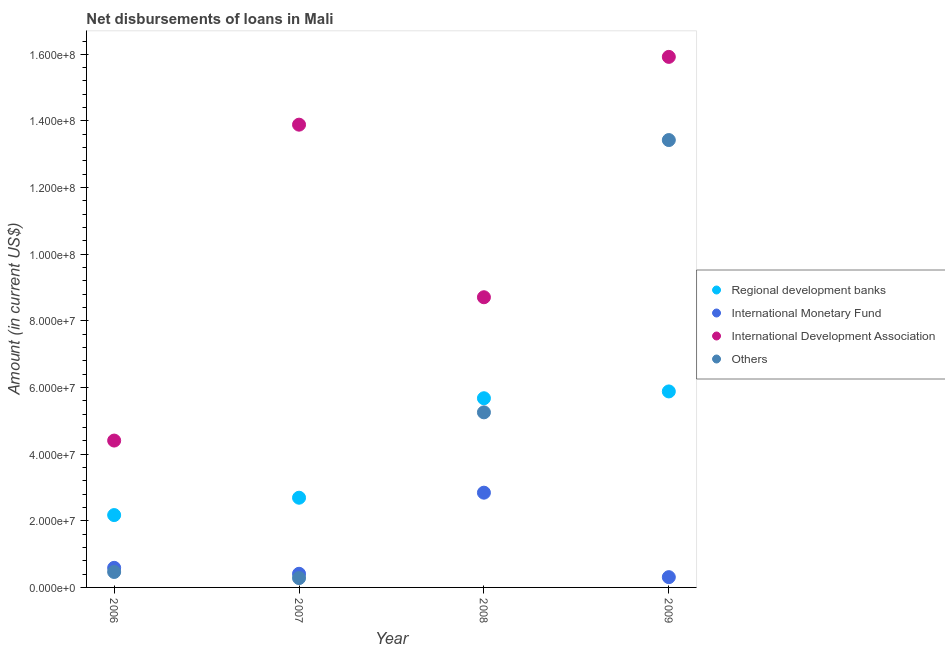How many different coloured dotlines are there?
Provide a succinct answer. 4. Is the number of dotlines equal to the number of legend labels?
Provide a succinct answer. Yes. What is the amount of loan disimbursed by international development association in 2006?
Provide a short and direct response. 4.41e+07. Across all years, what is the maximum amount of loan disimbursed by international monetary fund?
Your answer should be compact. 2.84e+07. Across all years, what is the minimum amount of loan disimbursed by international monetary fund?
Your answer should be compact. 3.08e+06. What is the total amount of loan disimbursed by international development association in the graph?
Your answer should be very brief. 4.29e+08. What is the difference between the amount of loan disimbursed by other organisations in 2007 and that in 2008?
Your answer should be compact. -4.97e+07. What is the difference between the amount of loan disimbursed by international development association in 2007 and the amount of loan disimbursed by other organisations in 2006?
Keep it short and to the point. 1.34e+08. What is the average amount of loan disimbursed by international monetary fund per year?
Keep it short and to the point. 1.04e+07. In the year 2007, what is the difference between the amount of loan disimbursed by international development association and amount of loan disimbursed by international monetary fund?
Give a very brief answer. 1.35e+08. What is the ratio of the amount of loan disimbursed by other organisations in 2007 to that in 2008?
Provide a short and direct response. 0.05. Is the amount of loan disimbursed by international monetary fund in 2007 less than that in 2008?
Offer a very short reply. Yes. Is the difference between the amount of loan disimbursed by regional development banks in 2007 and 2009 greater than the difference between the amount of loan disimbursed by international monetary fund in 2007 and 2009?
Offer a terse response. No. What is the difference between the highest and the second highest amount of loan disimbursed by international monetary fund?
Provide a short and direct response. 2.26e+07. What is the difference between the highest and the lowest amount of loan disimbursed by international development association?
Offer a terse response. 1.15e+08. Is it the case that in every year, the sum of the amount of loan disimbursed by regional development banks and amount of loan disimbursed by international monetary fund is greater than the amount of loan disimbursed by international development association?
Offer a terse response. No. Is the amount of loan disimbursed by international development association strictly greater than the amount of loan disimbursed by other organisations over the years?
Ensure brevity in your answer.  Yes. How many dotlines are there?
Keep it short and to the point. 4. Does the graph contain any zero values?
Give a very brief answer. No. Where does the legend appear in the graph?
Your response must be concise. Center right. How are the legend labels stacked?
Your response must be concise. Vertical. What is the title of the graph?
Give a very brief answer. Net disbursements of loans in Mali. Does "Insurance services" appear as one of the legend labels in the graph?
Make the answer very short. No. What is the Amount (in current US$) of Regional development banks in 2006?
Your response must be concise. 2.17e+07. What is the Amount (in current US$) in International Monetary Fund in 2006?
Offer a terse response. 5.88e+06. What is the Amount (in current US$) in International Development Association in 2006?
Make the answer very short. 4.41e+07. What is the Amount (in current US$) in Others in 2006?
Provide a short and direct response. 4.64e+06. What is the Amount (in current US$) in Regional development banks in 2007?
Your answer should be compact. 2.69e+07. What is the Amount (in current US$) of International Monetary Fund in 2007?
Your answer should be very brief. 4.09e+06. What is the Amount (in current US$) of International Development Association in 2007?
Make the answer very short. 1.39e+08. What is the Amount (in current US$) in Others in 2007?
Your response must be concise. 2.80e+06. What is the Amount (in current US$) in Regional development banks in 2008?
Your answer should be very brief. 5.68e+07. What is the Amount (in current US$) in International Monetary Fund in 2008?
Your answer should be very brief. 2.84e+07. What is the Amount (in current US$) of International Development Association in 2008?
Provide a succinct answer. 8.71e+07. What is the Amount (in current US$) in Others in 2008?
Keep it short and to the point. 5.25e+07. What is the Amount (in current US$) in Regional development banks in 2009?
Give a very brief answer. 5.88e+07. What is the Amount (in current US$) in International Monetary Fund in 2009?
Your answer should be compact. 3.08e+06. What is the Amount (in current US$) in International Development Association in 2009?
Ensure brevity in your answer.  1.59e+08. What is the Amount (in current US$) in Others in 2009?
Your response must be concise. 1.34e+08. Across all years, what is the maximum Amount (in current US$) of Regional development banks?
Provide a succinct answer. 5.88e+07. Across all years, what is the maximum Amount (in current US$) in International Monetary Fund?
Offer a very short reply. 2.84e+07. Across all years, what is the maximum Amount (in current US$) in International Development Association?
Provide a succinct answer. 1.59e+08. Across all years, what is the maximum Amount (in current US$) in Others?
Provide a succinct answer. 1.34e+08. Across all years, what is the minimum Amount (in current US$) in Regional development banks?
Your answer should be very brief. 2.17e+07. Across all years, what is the minimum Amount (in current US$) of International Monetary Fund?
Provide a short and direct response. 3.08e+06. Across all years, what is the minimum Amount (in current US$) of International Development Association?
Your response must be concise. 4.41e+07. Across all years, what is the minimum Amount (in current US$) in Others?
Offer a terse response. 2.80e+06. What is the total Amount (in current US$) in Regional development banks in the graph?
Offer a very short reply. 1.64e+08. What is the total Amount (in current US$) of International Monetary Fund in the graph?
Offer a terse response. 4.15e+07. What is the total Amount (in current US$) in International Development Association in the graph?
Offer a very short reply. 4.29e+08. What is the total Amount (in current US$) in Others in the graph?
Your response must be concise. 1.94e+08. What is the difference between the Amount (in current US$) of Regional development banks in 2006 and that in 2007?
Your response must be concise. -5.21e+06. What is the difference between the Amount (in current US$) of International Monetary Fund in 2006 and that in 2007?
Give a very brief answer. 1.79e+06. What is the difference between the Amount (in current US$) of International Development Association in 2006 and that in 2007?
Provide a short and direct response. -9.48e+07. What is the difference between the Amount (in current US$) in Others in 2006 and that in 2007?
Offer a very short reply. 1.83e+06. What is the difference between the Amount (in current US$) in Regional development banks in 2006 and that in 2008?
Make the answer very short. -3.51e+07. What is the difference between the Amount (in current US$) of International Monetary Fund in 2006 and that in 2008?
Offer a very short reply. -2.26e+07. What is the difference between the Amount (in current US$) in International Development Association in 2006 and that in 2008?
Give a very brief answer. -4.30e+07. What is the difference between the Amount (in current US$) of Others in 2006 and that in 2008?
Provide a succinct answer. -4.79e+07. What is the difference between the Amount (in current US$) in Regional development banks in 2006 and that in 2009?
Your answer should be compact. -3.71e+07. What is the difference between the Amount (in current US$) of International Monetary Fund in 2006 and that in 2009?
Keep it short and to the point. 2.80e+06. What is the difference between the Amount (in current US$) in International Development Association in 2006 and that in 2009?
Ensure brevity in your answer.  -1.15e+08. What is the difference between the Amount (in current US$) of Others in 2006 and that in 2009?
Keep it short and to the point. -1.30e+08. What is the difference between the Amount (in current US$) in Regional development banks in 2007 and that in 2008?
Your answer should be compact. -2.99e+07. What is the difference between the Amount (in current US$) in International Monetary Fund in 2007 and that in 2008?
Offer a terse response. -2.43e+07. What is the difference between the Amount (in current US$) in International Development Association in 2007 and that in 2008?
Your answer should be very brief. 5.18e+07. What is the difference between the Amount (in current US$) of Others in 2007 and that in 2008?
Provide a short and direct response. -4.97e+07. What is the difference between the Amount (in current US$) in Regional development banks in 2007 and that in 2009?
Offer a very short reply. -3.19e+07. What is the difference between the Amount (in current US$) in International Monetary Fund in 2007 and that in 2009?
Offer a terse response. 1.01e+06. What is the difference between the Amount (in current US$) of International Development Association in 2007 and that in 2009?
Give a very brief answer. -2.03e+07. What is the difference between the Amount (in current US$) of Others in 2007 and that in 2009?
Make the answer very short. -1.31e+08. What is the difference between the Amount (in current US$) in Regional development banks in 2008 and that in 2009?
Your response must be concise. -2.04e+06. What is the difference between the Amount (in current US$) in International Monetary Fund in 2008 and that in 2009?
Give a very brief answer. 2.54e+07. What is the difference between the Amount (in current US$) of International Development Association in 2008 and that in 2009?
Give a very brief answer. -7.21e+07. What is the difference between the Amount (in current US$) in Others in 2008 and that in 2009?
Make the answer very short. -8.17e+07. What is the difference between the Amount (in current US$) in Regional development banks in 2006 and the Amount (in current US$) in International Monetary Fund in 2007?
Your response must be concise. 1.76e+07. What is the difference between the Amount (in current US$) of Regional development banks in 2006 and the Amount (in current US$) of International Development Association in 2007?
Give a very brief answer. -1.17e+08. What is the difference between the Amount (in current US$) of Regional development banks in 2006 and the Amount (in current US$) of Others in 2007?
Your response must be concise. 1.89e+07. What is the difference between the Amount (in current US$) in International Monetary Fund in 2006 and the Amount (in current US$) in International Development Association in 2007?
Keep it short and to the point. -1.33e+08. What is the difference between the Amount (in current US$) of International Monetary Fund in 2006 and the Amount (in current US$) of Others in 2007?
Your answer should be compact. 3.08e+06. What is the difference between the Amount (in current US$) of International Development Association in 2006 and the Amount (in current US$) of Others in 2007?
Your answer should be compact. 4.13e+07. What is the difference between the Amount (in current US$) in Regional development banks in 2006 and the Amount (in current US$) in International Monetary Fund in 2008?
Make the answer very short. -6.72e+06. What is the difference between the Amount (in current US$) of Regional development banks in 2006 and the Amount (in current US$) of International Development Association in 2008?
Provide a succinct answer. -6.54e+07. What is the difference between the Amount (in current US$) in Regional development banks in 2006 and the Amount (in current US$) in Others in 2008?
Make the answer very short. -3.08e+07. What is the difference between the Amount (in current US$) in International Monetary Fund in 2006 and the Amount (in current US$) in International Development Association in 2008?
Offer a very short reply. -8.12e+07. What is the difference between the Amount (in current US$) in International Monetary Fund in 2006 and the Amount (in current US$) in Others in 2008?
Your response must be concise. -4.67e+07. What is the difference between the Amount (in current US$) of International Development Association in 2006 and the Amount (in current US$) of Others in 2008?
Your answer should be compact. -8.47e+06. What is the difference between the Amount (in current US$) of Regional development banks in 2006 and the Amount (in current US$) of International Monetary Fund in 2009?
Keep it short and to the point. 1.86e+07. What is the difference between the Amount (in current US$) of Regional development banks in 2006 and the Amount (in current US$) of International Development Association in 2009?
Provide a short and direct response. -1.38e+08. What is the difference between the Amount (in current US$) of Regional development banks in 2006 and the Amount (in current US$) of Others in 2009?
Offer a terse response. -1.13e+08. What is the difference between the Amount (in current US$) of International Monetary Fund in 2006 and the Amount (in current US$) of International Development Association in 2009?
Your answer should be compact. -1.53e+08. What is the difference between the Amount (in current US$) in International Monetary Fund in 2006 and the Amount (in current US$) in Others in 2009?
Make the answer very short. -1.28e+08. What is the difference between the Amount (in current US$) of International Development Association in 2006 and the Amount (in current US$) of Others in 2009?
Give a very brief answer. -9.02e+07. What is the difference between the Amount (in current US$) in Regional development banks in 2007 and the Amount (in current US$) in International Monetary Fund in 2008?
Make the answer very short. -1.52e+06. What is the difference between the Amount (in current US$) in Regional development banks in 2007 and the Amount (in current US$) in International Development Association in 2008?
Provide a succinct answer. -6.02e+07. What is the difference between the Amount (in current US$) of Regional development banks in 2007 and the Amount (in current US$) of Others in 2008?
Make the answer very short. -2.56e+07. What is the difference between the Amount (in current US$) in International Monetary Fund in 2007 and the Amount (in current US$) in International Development Association in 2008?
Provide a short and direct response. -8.30e+07. What is the difference between the Amount (in current US$) of International Monetary Fund in 2007 and the Amount (in current US$) of Others in 2008?
Offer a terse response. -4.85e+07. What is the difference between the Amount (in current US$) of International Development Association in 2007 and the Amount (in current US$) of Others in 2008?
Offer a very short reply. 8.63e+07. What is the difference between the Amount (in current US$) in Regional development banks in 2007 and the Amount (in current US$) in International Monetary Fund in 2009?
Provide a succinct answer. 2.38e+07. What is the difference between the Amount (in current US$) in Regional development banks in 2007 and the Amount (in current US$) in International Development Association in 2009?
Your response must be concise. -1.32e+08. What is the difference between the Amount (in current US$) in Regional development banks in 2007 and the Amount (in current US$) in Others in 2009?
Ensure brevity in your answer.  -1.07e+08. What is the difference between the Amount (in current US$) in International Monetary Fund in 2007 and the Amount (in current US$) in International Development Association in 2009?
Give a very brief answer. -1.55e+08. What is the difference between the Amount (in current US$) in International Monetary Fund in 2007 and the Amount (in current US$) in Others in 2009?
Offer a terse response. -1.30e+08. What is the difference between the Amount (in current US$) of International Development Association in 2007 and the Amount (in current US$) of Others in 2009?
Provide a succinct answer. 4.62e+06. What is the difference between the Amount (in current US$) in Regional development banks in 2008 and the Amount (in current US$) in International Monetary Fund in 2009?
Ensure brevity in your answer.  5.37e+07. What is the difference between the Amount (in current US$) of Regional development banks in 2008 and the Amount (in current US$) of International Development Association in 2009?
Offer a terse response. -1.02e+08. What is the difference between the Amount (in current US$) in Regional development banks in 2008 and the Amount (in current US$) in Others in 2009?
Your response must be concise. -7.75e+07. What is the difference between the Amount (in current US$) of International Monetary Fund in 2008 and the Amount (in current US$) of International Development Association in 2009?
Make the answer very short. -1.31e+08. What is the difference between the Amount (in current US$) in International Monetary Fund in 2008 and the Amount (in current US$) in Others in 2009?
Give a very brief answer. -1.06e+08. What is the difference between the Amount (in current US$) in International Development Association in 2008 and the Amount (in current US$) in Others in 2009?
Provide a short and direct response. -4.72e+07. What is the average Amount (in current US$) of Regional development banks per year?
Make the answer very short. 4.11e+07. What is the average Amount (in current US$) in International Monetary Fund per year?
Provide a succinct answer. 1.04e+07. What is the average Amount (in current US$) in International Development Association per year?
Make the answer very short. 1.07e+08. What is the average Amount (in current US$) in Others per year?
Your answer should be compact. 4.86e+07. In the year 2006, what is the difference between the Amount (in current US$) in Regional development banks and Amount (in current US$) in International Monetary Fund?
Your answer should be very brief. 1.58e+07. In the year 2006, what is the difference between the Amount (in current US$) of Regional development banks and Amount (in current US$) of International Development Association?
Your answer should be very brief. -2.24e+07. In the year 2006, what is the difference between the Amount (in current US$) of Regional development banks and Amount (in current US$) of Others?
Give a very brief answer. 1.71e+07. In the year 2006, what is the difference between the Amount (in current US$) of International Monetary Fund and Amount (in current US$) of International Development Association?
Ensure brevity in your answer.  -3.82e+07. In the year 2006, what is the difference between the Amount (in current US$) of International Monetary Fund and Amount (in current US$) of Others?
Your response must be concise. 1.24e+06. In the year 2006, what is the difference between the Amount (in current US$) of International Development Association and Amount (in current US$) of Others?
Ensure brevity in your answer.  3.94e+07. In the year 2007, what is the difference between the Amount (in current US$) in Regional development banks and Amount (in current US$) in International Monetary Fund?
Offer a very short reply. 2.28e+07. In the year 2007, what is the difference between the Amount (in current US$) in Regional development banks and Amount (in current US$) in International Development Association?
Ensure brevity in your answer.  -1.12e+08. In the year 2007, what is the difference between the Amount (in current US$) of Regional development banks and Amount (in current US$) of Others?
Provide a succinct answer. 2.41e+07. In the year 2007, what is the difference between the Amount (in current US$) in International Monetary Fund and Amount (in current US$) in International Development Association?
Provide a succinct answer. -1.35e+08. In the year 2007, what is the difference between the Amount (in current US$) in International Monetary Fund and Amount (in current US$) in Others?
Provide a short and direct response. 1.29e+06. In the year 2007, what is the difference between the Amount (in current US$) in International Development Association and Amount (in current US$) in Others?
Provide a succinct answer. 1.36e+08. In the year 2008, what is the difference between the Amount (in current US$) of Regional development banks and Amount (in current US$) of International Monetary Fund?
Give a very brief answer. 2.83e+07. In the year 2008, what is the difference between the Amount (in current US$) in Regional development banks and Amount (in current US$) in International Development Association?
Offer a very short reply. -3.03e+07. In the year 2008, what is the difference between the Amount (in current US$) in Regional development banks and Amount (in current US$) in Others?
Offer a very short reply. 4.24e+06. In the year 2008, what is the difference between the Amount (in current US$) of International Monetary Fund and Amount (in current US$) of International Development Association?
Your response must be concise. -5.87e+07. In the year 2008, what is the difference between the Amount (in current US$) in International Monetary Fund and Amount (in current US$) in Others?
Provide a short and direct response. -2.41e+07. In the year 2008, what is the difference between the Amount (in current US$) in International Development Association and Amount (in current US$) in Others?
Provide a short and direct response. 3.45e+07. In the year 2009, what is the difference between the Amount (in current US$) of Regional development banks and Amount (in current US$) of International Monetary Fund?
Give a very brief answer. 5.57e+07. In the year 2009, what is the difference between the Amount (in current US$) of Regional development banks and Amount (in current US$) of International Development Association?
Your response must be concise. -1.00e+08. In the year 2009, what is the difference between the Amount (in current US$) in Regional development banks and Amount (in current US$) in Others?
Ensure brevity in your answer.  -7.54e+07. In the year 2009, what is the difference between the Amount (in current US$) of International Monetary Fund and Amount (in current US$) of International Development Association?
Your response must be concise. -1.56e+08. In the year 2009, what is the difference between the Amount (in current US$) in International Monetary Fund and Amount (in current US$) in Others?
Keep it short and to the point. -1.31e+08. In the year 2009, what is the difference between the Amount (in current US$) of International Development Association and Amount (in current US$) of Others?
Your response must be concise. 2.50e+07. What is the ratio of the Amount (in current US$) in Regional development banks in 2006 to that in 2007?
Offer a terse response. 0.81. What is the ratio of the Amount (in current US$) of International Monetary Fund in 2006 to that in 2007?
Provide a short and direct response. 1.44. What is the ratio of the Amount (in current US$) in International Development Association in 2006 to that in 2007?
Offer a terse response. 0.32. What is the ratio of the Amount (in current US$) in Others in 2006 to that in 2007?
Ensure brevity in your answer.  1.65. What is the ratio of the Amount (in current US$) in Regional development banks in 2006 to that in 2008?
Make the answer very short. 0.38. What is the ratio of the Amount (in current US$) of International Monetary Fund in 2006 to that in 2008?
Make the answer very short. 0.21. What is the ratio of the Amount (in current US$) of International Development Association in 2006 to that in 2008?
Provide a succinct answer. 0.51. What is the ratio of the Amount (in current US$) in Others in 2006 to that in 2008?
Make the answer very short. 0.09. What is the ratio of the Amount (in current US$) of Regional development banks in 2006 to that in 2009?
Your answer should be compact. 0.37. What is the ratio of the Amount (in current US$) in International Monetary Fund in 2006 to that in 2009?
Offer a very short reply. 1.91. What is the ratio of the Amount (in current US$) of International Development Association in 2006 to that in 2009?
Give a very brief answer. 0.28. What is the ratio of the Amount (in current US$) of Others in 2006 to that in 2009?
Keep it short and to the point. 0.03. What is the ratio of the Amount (in current US$) in Regional development banks in 2007 to that in 2008?
Ensure brevity in your answer.  0.47. What is the ratio of the Amount (in current US$) in International Monetary Fund in 2007 to that in 2008?
Your answer should be compact. 0.14. What is the ratio of the Amount (in current US$) in International Development Association in 2007 to that in 2008?
Your answer should be very brief. 1.59. What is the ratio of the Amount (in current US$) in Others in 2007 to that in 2008?
Your answer should be very brief. 0.05. What is the ratio of the Amount (in current US$) of Regional development banks in 2007 to that in 2009?
Your response must be concise. 0.46. What is the ratio of the Amount (in current US$) in International Monetary Fund in 2007 to that in 2009?
Offer a very short reply. 1.33. What is the ratio of the Amount (in current US$) of International Development Association in 2007 to that in 2009?
Offer a terse response. 0.87. What is the ratio of the Amount (in current US$) in Others in 2007 to that in 2009?
Your answer should be very brief. 0.02. What is the ratio of the Amount (in current US$) in Regional development banks in 2008 to that in 2009?
Make the answer very short. 0.97. What is the ratio of the Amount (in current US$) in International Monetary Fund in 2008 to that in 2009?
Give a very brief answer. 9.22. What is the ratio of the Amount (in current US$) in International Development Association in 2008 to that in 2009?
Give a very brief answer. 0.55. What is the ratio of the Amount (in current US$) in Others in 2008 to that in 2009?
Make the answer very short. 0.39. What is the difference between the highest and the second highest Amount (in current US$) in Regional development banks?
Keep it short and to the point. 2.04e+06. What is the difference between the highest and the second highest Amount (in current US$) of International Monetary Fund?
Your answer should be very brief. 2.26e+07. What is the difference between the highest and the second highest Amount (in current US$) of International Development Association?
Your answer should be compact. 2.03e+07. What is the difference between the highest and the second highest Amount (in current US$) of Others?
Ensure brevity in your answer.  8.17e+07. What is the difference between the highest and the lowest Amount (in current US$) in Regional development banks?
Offer a very short reply. 3.71e+07. What is the difference between the highest and the lowest Amount (in current US$) of International Monetary Fund?
Your response must be concise. 2.54e+07. What is the difference between the highest and the lowest Amount (in current US$) of International Development Association?
Keep it short and to the point. 1.15e+08. What is the difference between the highest and the lowest Amount (in current US$) of Others?
Your response must be concise. 1.31e+08. 